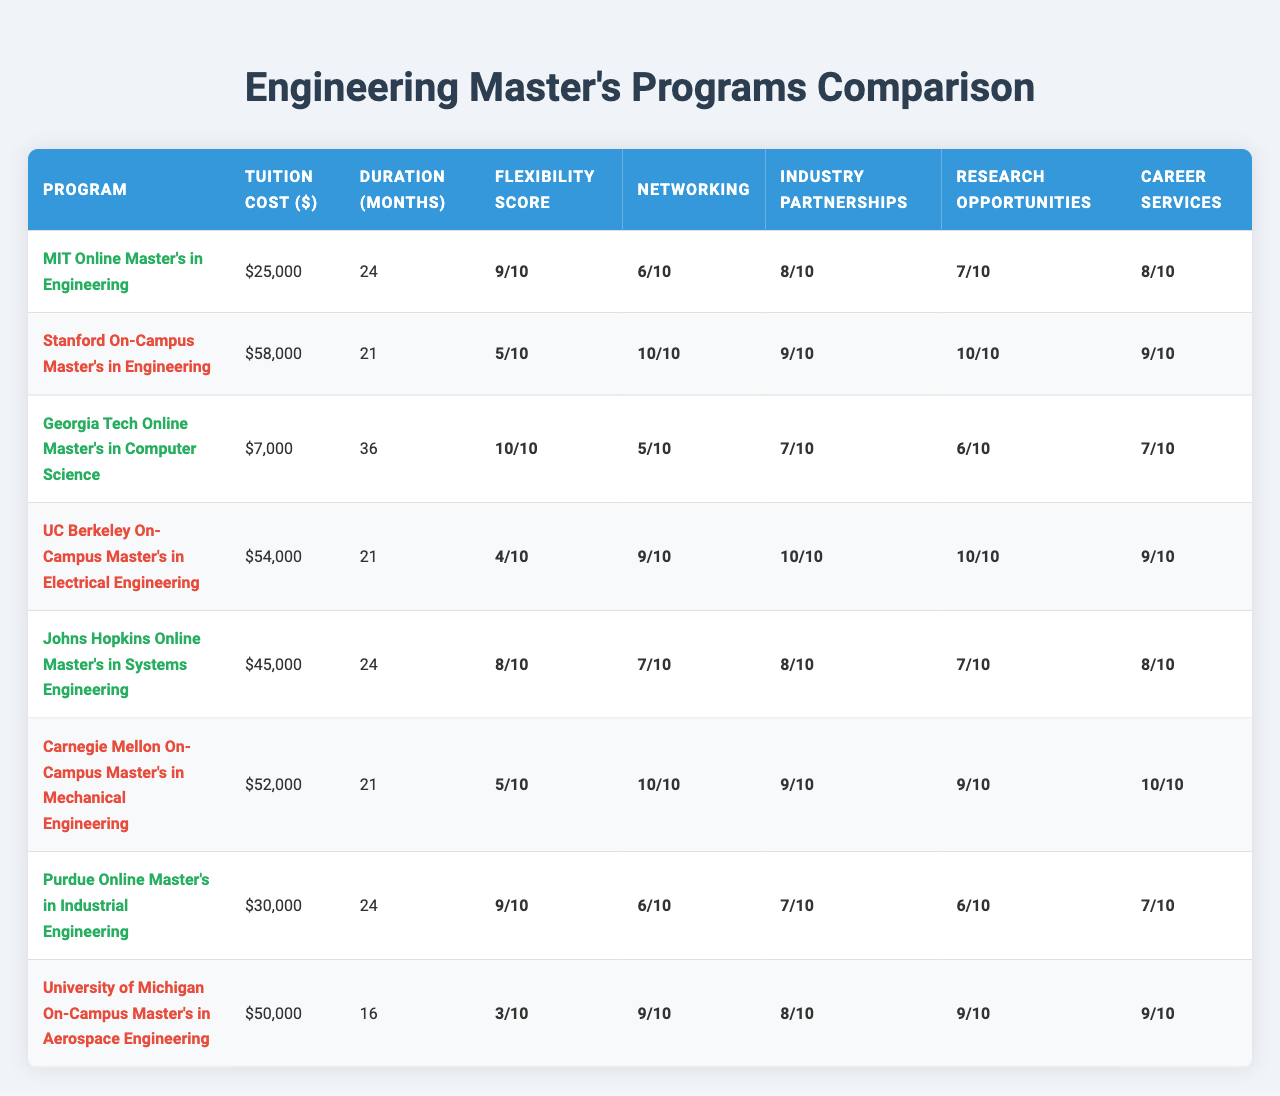What's the tuition cost for the MIT Online Master's in Engineering? The table shows that the tuition cost listed for the MIT Online Master's program is $25,000.
Answer: $25,000 What is the program duration for the UC Berkeley On-Campus Master's in Electrical Engineering? According to the table, the program duration for UC Berkeley's On-Campus Master's is 21 months.
Answer: 21 months Which online program has the highest flexibility score? By checking the flexibility scores for online programs, the Georgia Tech Online Master's in Computer Science has the highest score of 10.
Answer: Georgia Tech Online Master's in Computer Science What is the average tuition cost of the on-campus programs? The tuition costs for the on-campus programs are $58,000, $54,000, $52,000, and $50,000. The sum is $214,000 and divided by four (number of on-campus programs) gives an average of $53,500.
Answer: $53,500 Is the career services rating higher for the online programs compared to the on-campus programs? Upon checking, the average career services rating for online programs is (8 + 8 + 7 + 8)/4 = 7.75 while for on-campus programs it is (9 + 9 + 10 + 9)/4 = 9.25. Therefore, the on-campus programs have a higher rating.
Answer: No Which program has the highest industry partnerships score among online programs? Among the online programs, the Johns Hopkins Online Master's in Systems Engineering and MIT Online Master's in Engineering both have an industry partnerships score of 8, which is the highest.
Answer: Johns Hopkins Online Master's and MIT Online Master's What is the difference in program duration between the longest and shortest online programs? The longest online program is the Georgia Tech Online Master's in Computer Science at 36 months and the shortest, Purdue Online Master's in Industrial Engineering, at 24 months. The difference is 36 - 24 = 12 months.
Answer: 12 months Does the University of Michigan On-Campus Master's in Aerospace Engineering have a lower flexibility score than the Stanford On-Campus Master's in Engineering? The flexibility score for the University of Michigan program is 3 while for the Stanford program, it is 5. Since 3 is less than 5, the statement is true.
Answer: Yes What is the total career services rating for all programs combined? Adding the career services ratings for each program: 8 + 9 + 7 + 9 + 8 + 10 + 7 + 9 gives a total of 67.
Answer: 67 Which on-campus program has the best networking opportunities score? Looking at the networking opportunities scores, the Carnegie Mellon On-Campus Master's in Mechanical Engineering has the highest score of 10.
Answer: Carnegie Mellon On-Campus Master's in Mechanical Engineering What is the average flexibility score for all programs? Adding the flexibility scores: 9 + 5 + 10 + 4 + 8 + 5 + 9 + 3 = 63. Dividing by 8 (the number of programs) gives an average flexibility score of 63/8 = 7.875, which rounds to 7.88.
Answer: 7.88 